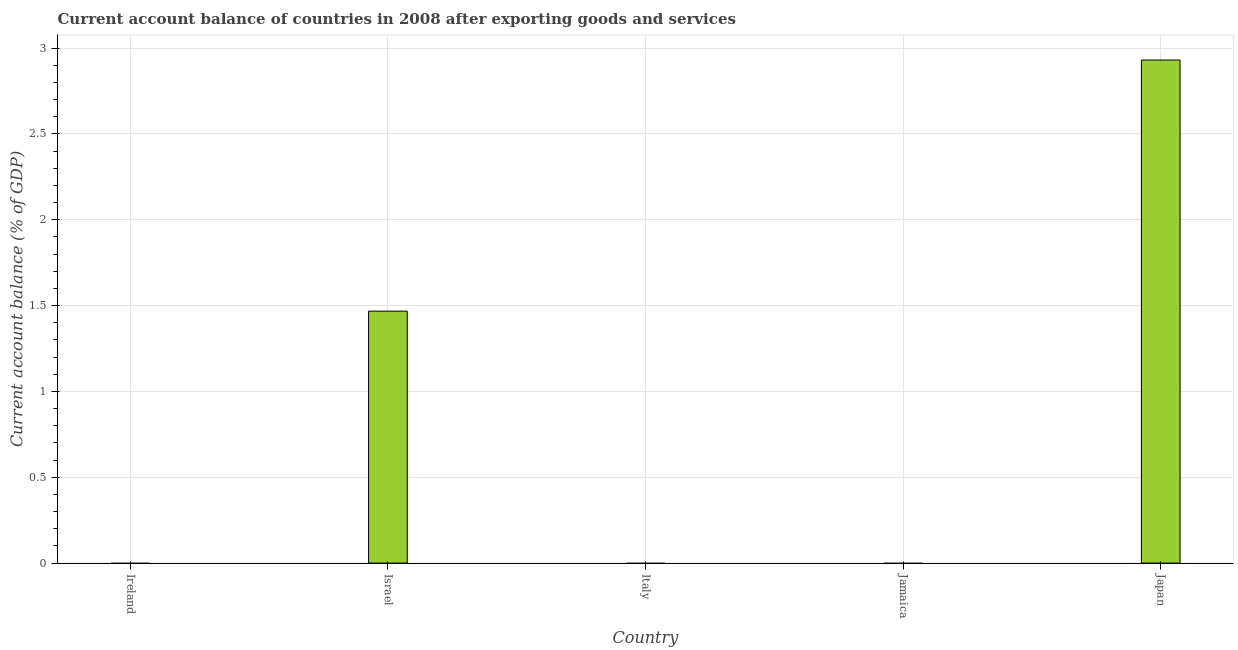Does the graph contain grids?
Your answer should be compact. Yes. What is the title of the graph?
Your answer should be compact. Current account balance of countries in 2008 after exporting goods and services. What is the label or title of the X-axis?
Provide a succinct answer. Country. What is the label or title of the Y-axis?
Offer a terse response. Current account balance (% of GDP). What is the current account balance in Ireland?
Keep it short and to the point. 0. Across all countries, what is the maximum current account balance?
Give a very brief answer. 2.93. In which country was the current account balance maximum?
Provide a succinct answer. Japan. What is the sum of the current account balance?
Make the answer very short. 4.4. What is the difference between the current account balance in Israel and Japan?
Provide a short and direct response. -1.46. What is the average current account balance per country?
Your response must be concise. 0.88. What is the median current account balance?
Ensure brevity in your answer.  0. What is the difference between the highest and the lowest current account balance?
Your answer should be compact. 2.93. Are all the bars in the graph horizontal?
Your answer should be compact. No. How many countries are there in the graph?
Provide a succinct answer. 5. What is the difference between two consecutive major ticks on the Y-axis?
Offer a very short reply. 0.5. Are the values on the major ticks of Y-axis written in scientific E-notation?
Your answer should be compact. No. What is the Current account balance (% of GDP) in Israel?
Offer a very short reply. 1.47. What is the Current account balance (% of GDP) in Italy?
Provide a succinct answer. 0. What is the Current account balance (% of GDP) in Jamaica?
Ensure brevity in your answer.  0. What is the Current account balance (% of GDP) of Japan?
Offer a terse response. 2.93. What is the difference between the Current account balance (% of GDP) in Israel and Japan?
Make the answer very short. -1.46. What is the ratio of the Current account balance (% of GDP) in Israel to that in Japan?
Your response must be concise. 0.5. 